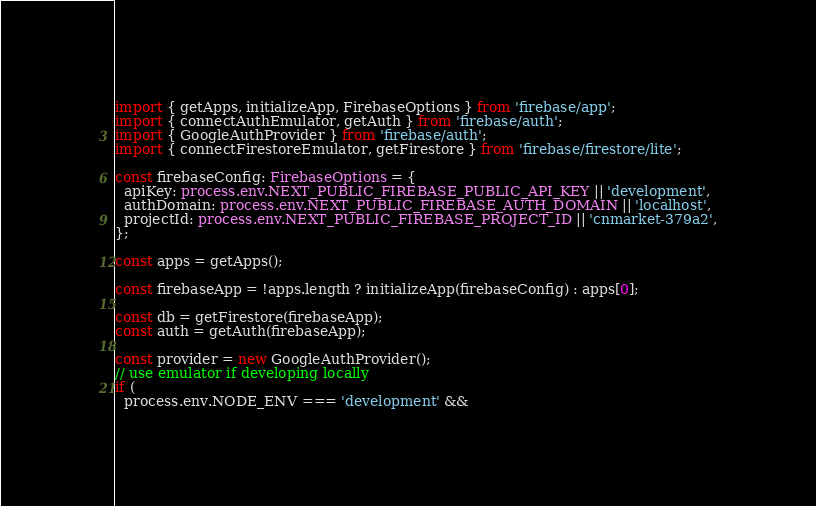<code> <loc_0><loc_0><loc_500><loc_500><_TypeScript_>import { getApps, initializeApp, FirebaseOptions } from 'firebase/app';
import { connectAuthEmulator, getAuth } from 'firebase/auth';
import { GoogleAuthProvider } from 'firebase/auth';
import { connectFirestoreEmulator, getFirestore } from 'firebase/firestore/lite';

const firebaseConfig: FirebaseOptions = {
  apiKey: process.env.NEXT_PUBLIC_FIREBASE_PUBLIC_API_KEY || 'development',
  authDomain: process.env.NEXT_PUBLIC_FIREBASE_AUTH_DOMAIN || 'localhost',
  projectId: process.env.NEXT_PUBLIC_FIREBASE_PROJECT_ID || 'cnmarket-379a2',
};

const apps = getApps();

const firebaseApp = !apps.length ? initializeApp(firebaseConfig) : apps[0];

const db = getFirestore(firebaseApp);
const auth = getAuth(firebaseApp);

const provider = new GoogleAuthProvider();
// use emulator if developing locally
if (
  process.env.NODE_ENV === 'development' &&</code> 